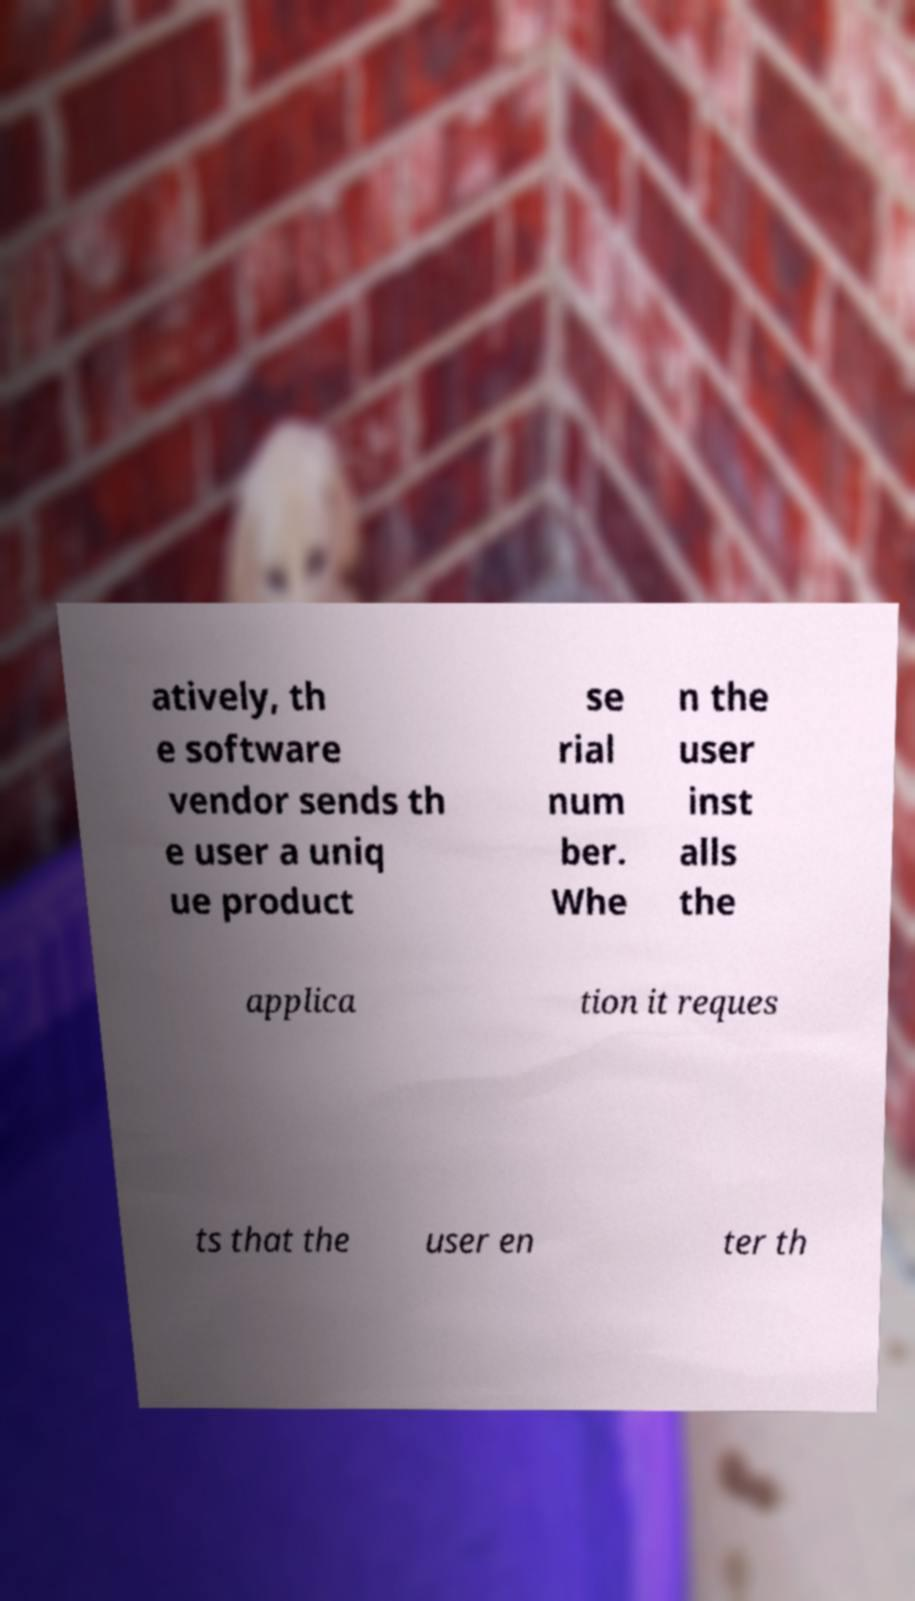Could you extract and type out the text from this image? atively, th e software vendor sends th e user a uniq ue product se rial num ber. Whe n the user inst alls the applica tion it reques ts that the user en ter th 